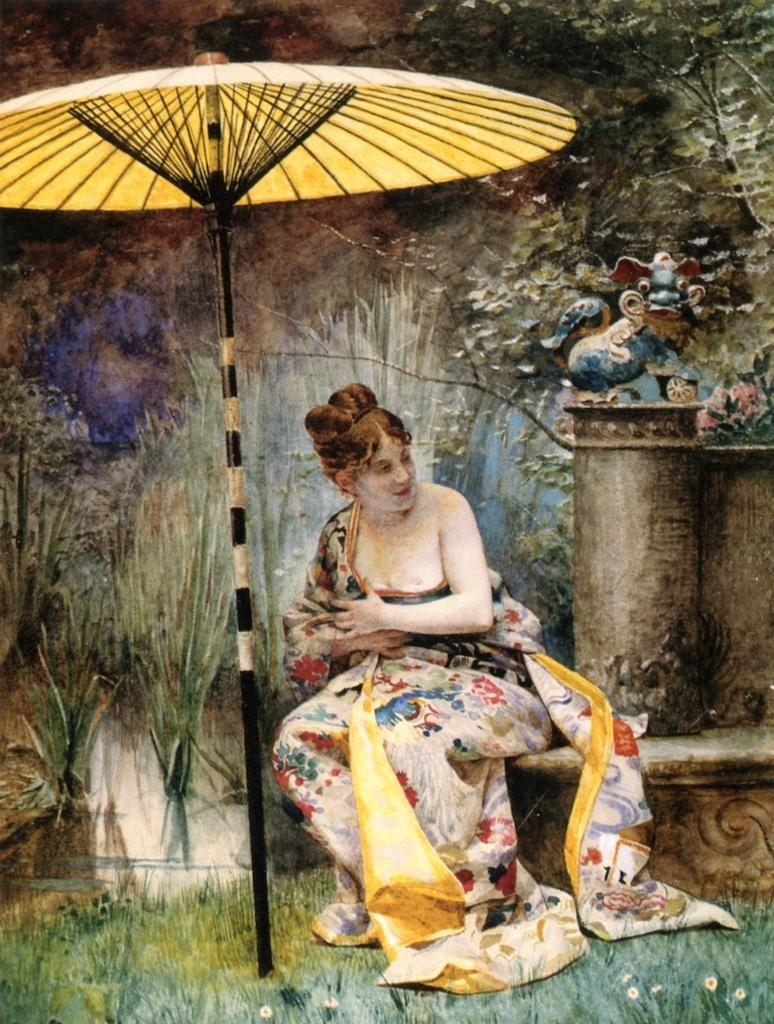What is the main subject in the center of the image? There is a woman sitting in the center of the image. What object is located beside the woman? There is an umbrella beside the woman. What type of natural environment is visible in the image? There are plants and grass visible in the image. What type of objects are present in the image that might be used for play? There are toys present in the image. Can you tell me how many toes the woman has on her left foot in the image? The image does not provide enough detail to determine the number of toes on the woman's left foot. 